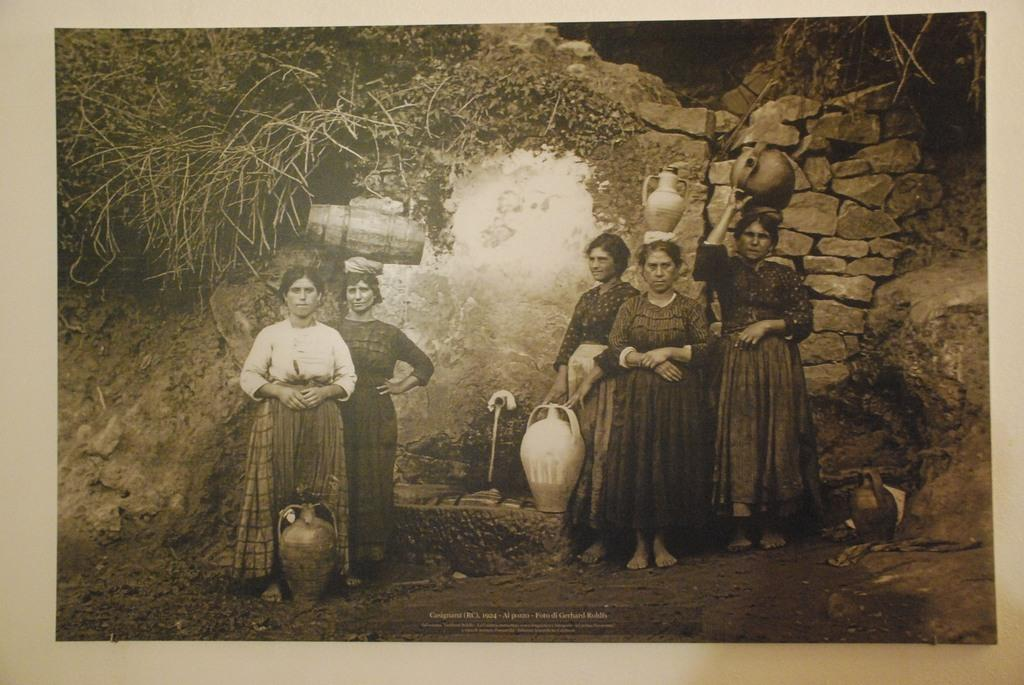What can be seen in the background of the image? The women are standing in front of a cave in the background. What are the women doing in the image? The women are holding objects on their heads and hands. Can you describe the appearance of the image? The image appears to be old. What type of quartz can be seen in the hands of the women in the image? There is no quartz present in the image; the women are holding unspecified objects on their heads and hands. 